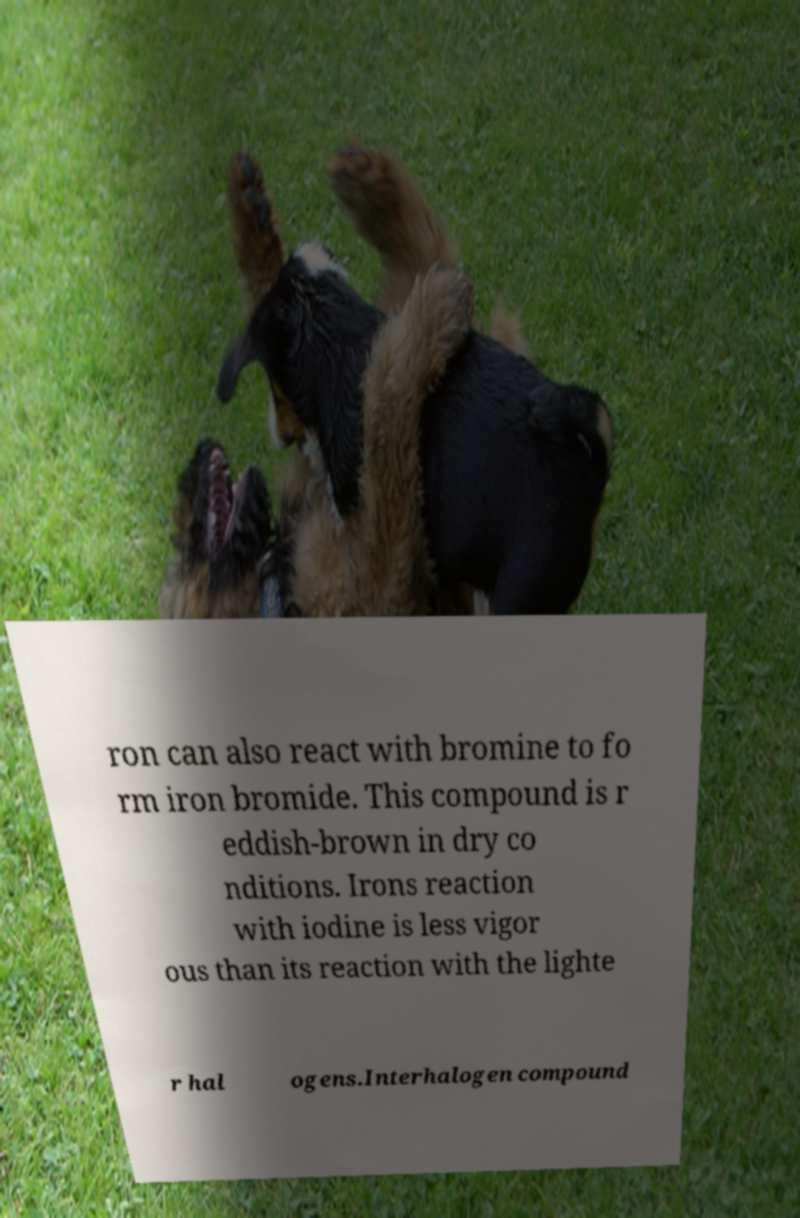For documentation purposes, I need the text within this image transcribed. Could you provide that? ron can also react with bromine to fo rm iron bromide. This compound is r eddish-brown in dry co nditions. Irons reaction with iodine is less vigor ous than its reaction with the lighte r hal ogens.Interhalogen compound 